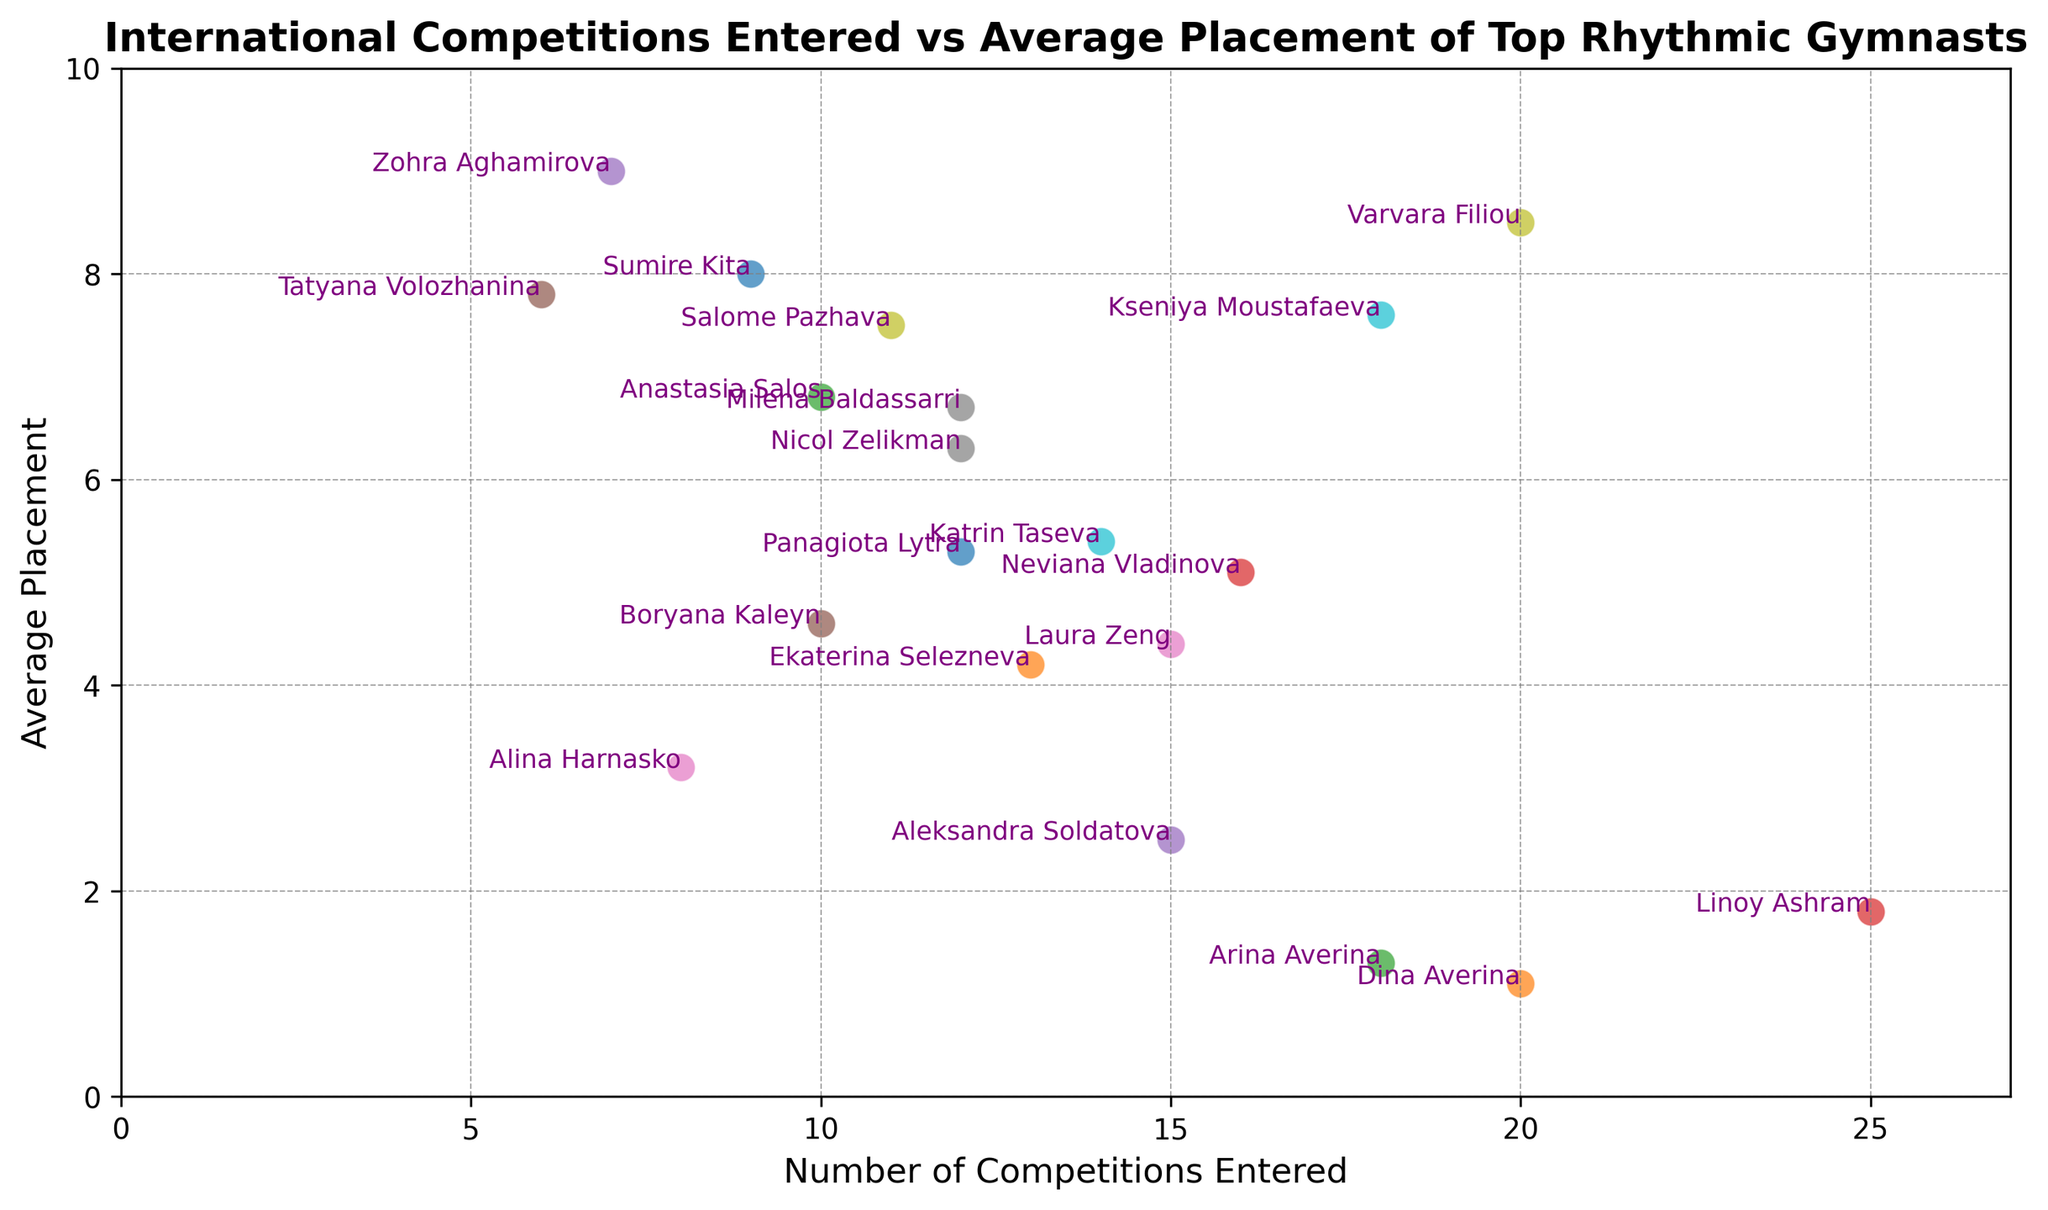What's the number of competitions entered by Panagiota Lytra? According to the scatter plot, locate the data point labeled "Panagiota Lytra." The x-axis represents the number of competitions entered. The value next to "Panagiota Lytra" on the x-axis is 12.
Answer: 12 Compare the average placement of Dina Averina and Arina Averina. Who has a better average placement? Look at the data points labeled "Dina Averina" and "Arina Averina." The y-axis represents the average placement. Dina Averina has an average placement of 1.1, whereas Arina Averina has an average placement of 1.3. Since a lower average placement is better, Dina Averina has a better average placement.
Answer: Dina Averina How many gymnasts have participated in more than 15 competitions? To determine this, count the number of data points where the x-axis value (number of competitions entered) is greater than 15. Gymnasts who fit this criterion: Dina Averina (20), Arina Averina (18), Linoy Ashram (25), Varvara Filiou (20), and Kseniya Moustafaeva (18). This totals to 5 gymnasts.
Answer: 5 What's the relationship between the number of competitions entered and the average placement for gymnasts with more than 15 competitions? Are there exceptions? Identify the data points representing gymnasts with more than 15 competitions (Dina Averina, Arina Averina, Linoy Ashram, Varvara Filiou, and Kseniya Moustafaeva). Generally, these gymnasts have very low average placements (indicating better performance), except for Varvara Filiou and Kseniya Moustafaeva who have higher average placements. Thus, there are exceptions.
Answer: Mostly better, with exceptions Which gymnast has the worst average placement among those who entered at least 10 competitions? Look for the highest y-axis value (representing the worst average placement) among the data points where the x-axis value (number of competitions entered) is at least 10. The worst average placement among these gymnasts is by Varvara Filiou, who has an average placement of 8.5.
Answer: Varvara Filiou What is the average of the average placements of gymnasts who entered exactly 12 competitions? Identify gymnasts with exactly 12 competitions (Panagiota Lytra, Milena Baldassarri, Nicol Zelikman). Their average placements are 5.3, 6.7, and 6.3 respectively. Calculate the average of these numbers: (5.3 + 6.7 + 6.3) / 3 = 6.1.
Answer: 6.1 Find the gymnast with the closest average placement to Panagiota Lytra. Look for the gymnast whose y-axis value is closest to Panagiota Lytra's average placement of 5.3. Ekaterina Selezneva with 4.2 and Katrin Taseva with 5.4 are nearby. Comparing, 5.4 is closer than 4.2. Thus, Katrin Taseva has the closest average placement.
Answer: Katrin Taseva 